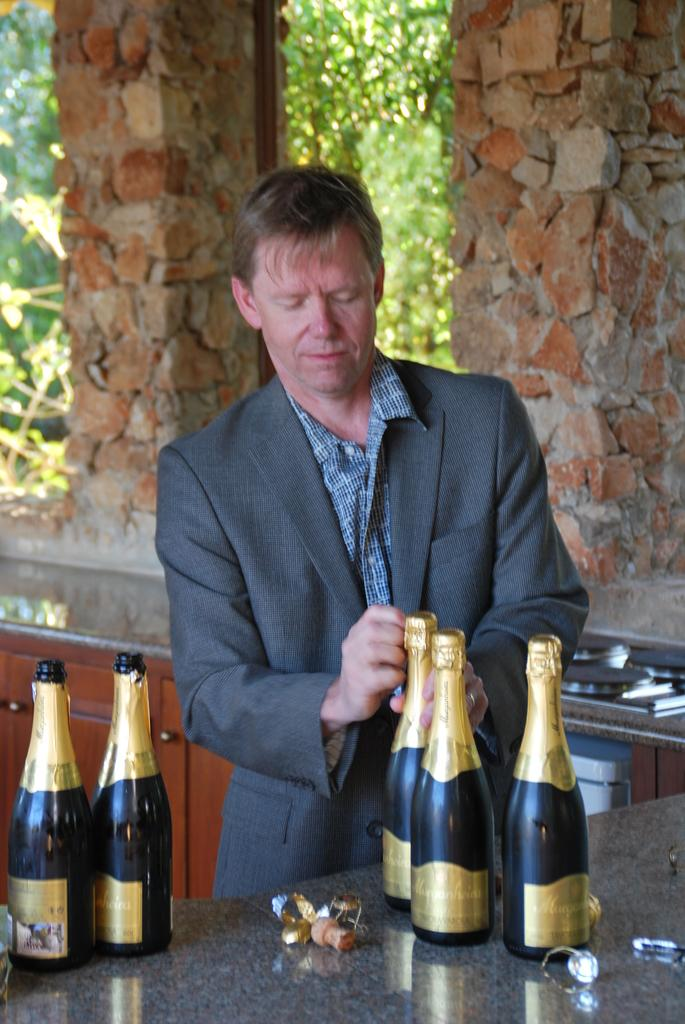Who is present in the image? There is a man in the image. What is the man wearing? The man is wearing a suit. What objects are in front of the man? There are bottles in front of the man. What can be seen in the background of the image? There is a stone wall in the background of the image. What type of memory is the man trying to recall in the image? There is no indication in the image that the man is trying to recall any memory. 